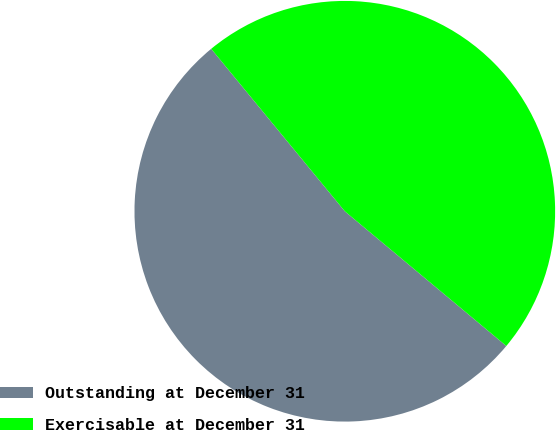Convert chart to OTSL. <chart><loc_0><loc_0><loc_500><loc_500><pie_chart><fcel>Outstanding at December 31<fcel>Exercisable at December 31<nl><fcel>52.98%<fcel>47.02%<nl></chart> 